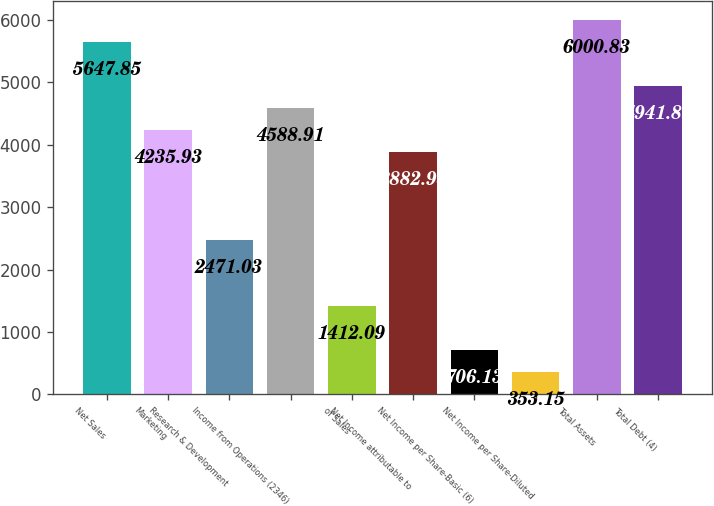Convert chart to OTSL. <chart><loc_0><loc_0><loc_500><loc_500><bar_chart><fcel>Net Sales<fcel>Marketing<fcel>Research & Development<fcel>Income from Operations (2346)<fcel>of Sales<fcel>Net Income attributable to<fcel>Net Income per Share-Basic (6)<fcel>Net Income per Share-Diluted<fcel>Total Assets<fcel>Total Debt (4)<nl><fcel>5647.85<fcel>4235.93<fcel>2471.03<fcel>4588.91<fcel>1412.09<fcel>3882.95<fcel>706.13<fcel>353.15<fcel>6000.83<fcel>4941.89<nl></chart> 